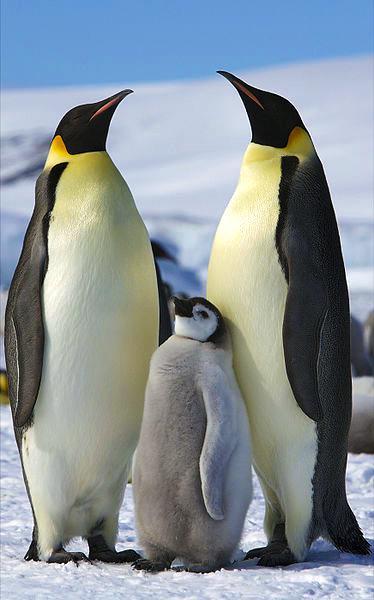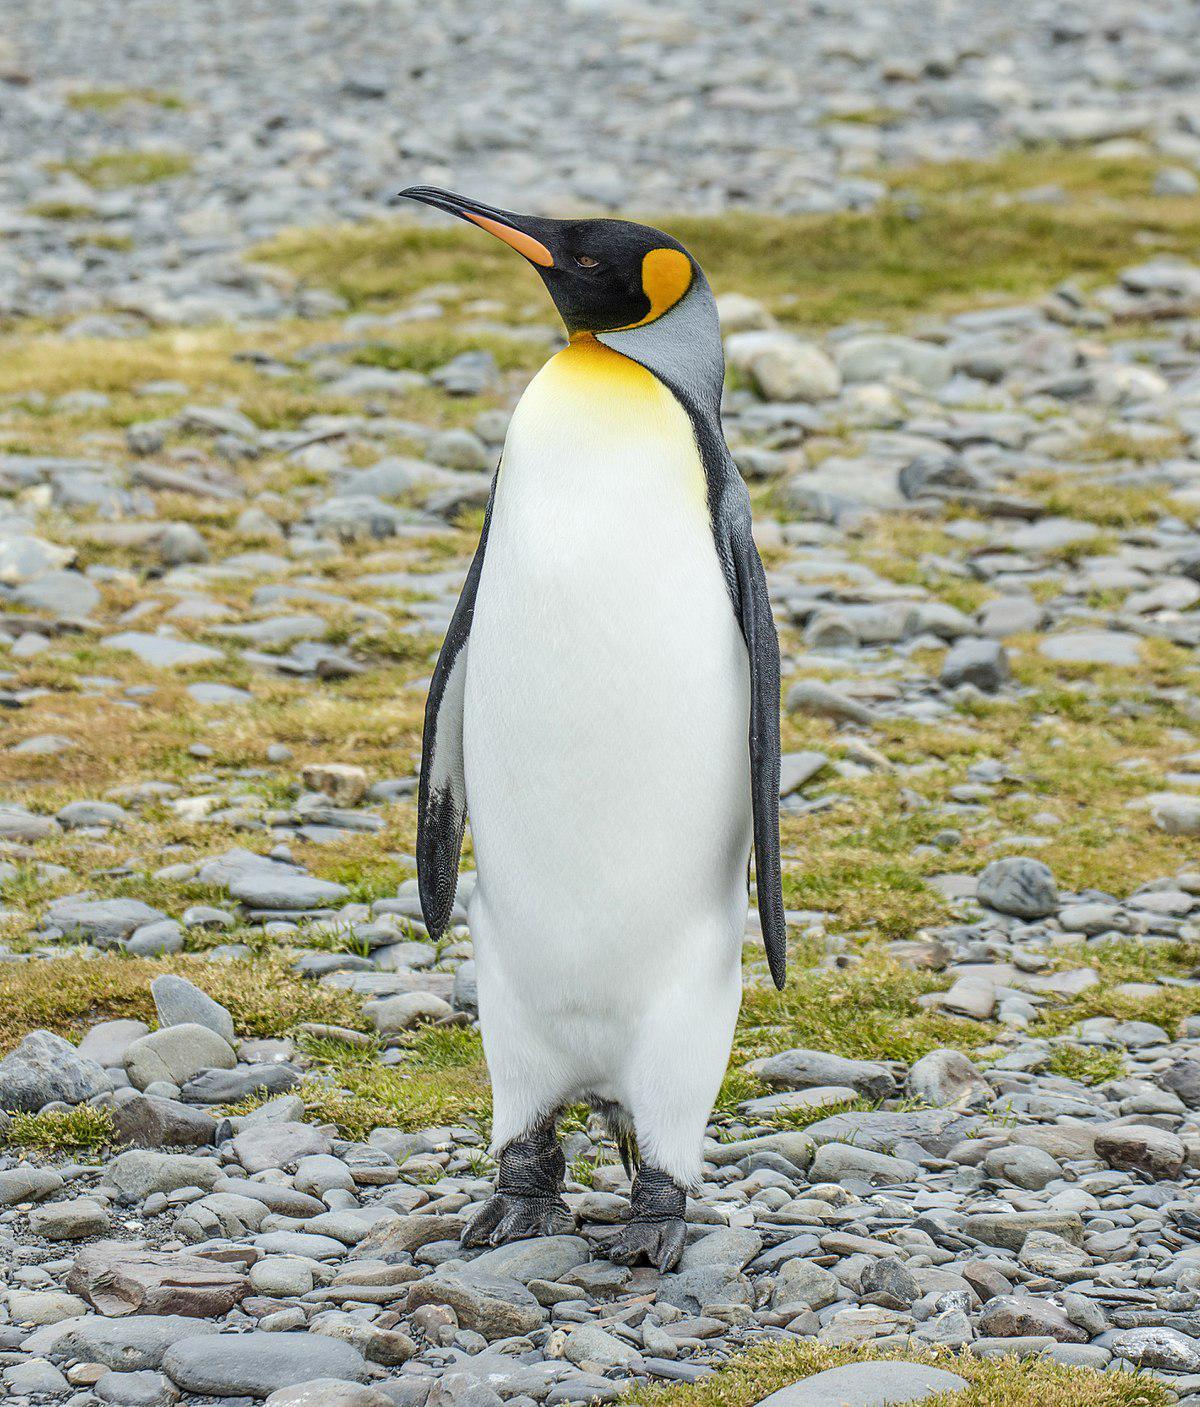The first image is the image on the left, the second image is the image on the right. For the images shown, is this caption "There are four penguins" true? Answer yes or no. Yes. 